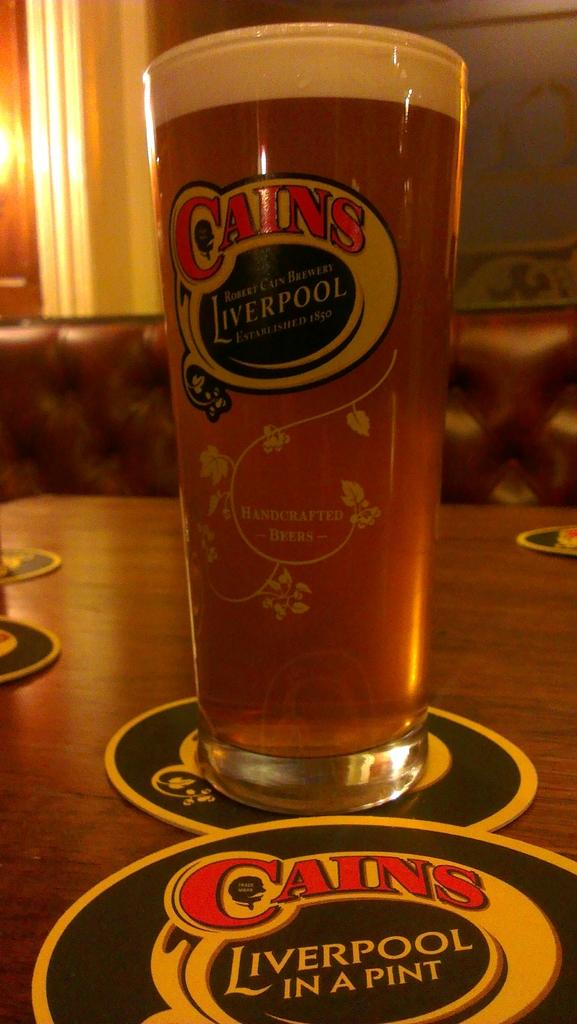What is the main object visible in the image? There is a glass in the image. What type of surface are the objects on? The objects are on a wooden surface in the image. What can be seen in the background of the image? There is a wall visible in the background of the image, and there are other objects present as well. What advertisement can be seen on the wall in the image? There is no advertisement visible on the wall in the image. What type of uniform is the fireman wearing in the image? There is no fireman present in the image. 